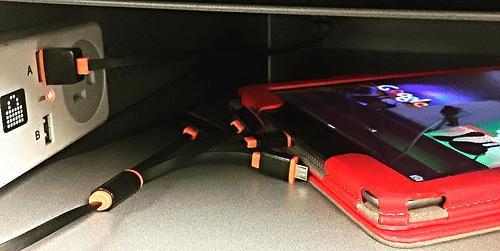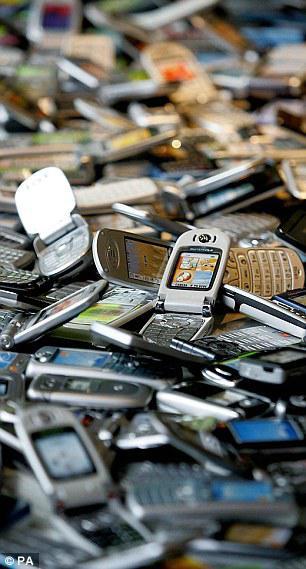The first image is the image on the left, the second image is the image on the right. Considering the images on both sides, is "There are more phones in the left image than in the right image." valid? Answer yes or no. No. The first image is the image on the left, the second image is the image on the right. Considering the images on both sides, is "The phones in each of the image are stacked upon each other." valid? Answer yes or no. No. 